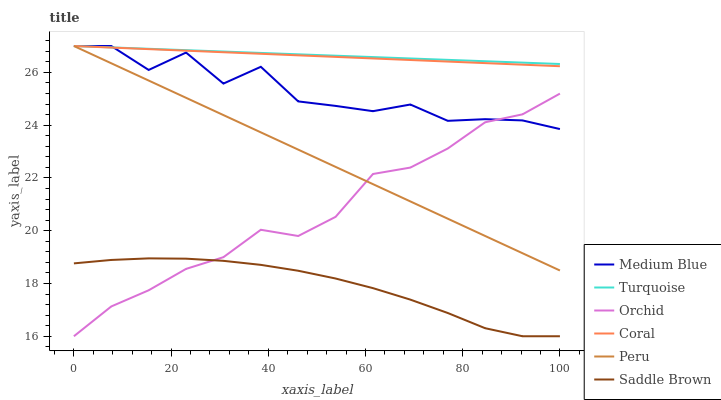Does Saddle Brown have the minimum area under the curve?
Answer yes or no. Yes. Does Turquoise have the maximum area under the curve?
Answer yes or no. Yes. Does Coral have the minimum area under the curve?
Answer yes or no. No. Does Coral have the maximum area under the curve?
Answer yes or no. No. Is Turquoise the smoothest?
Answer yes or no. Yes. Is Medium Blue the roughest?
Answer yes or no. Yes. Is Coral the smoothest?
Answer yes or no. No. Is Coral the roughest?
Answer yes or no. No. Does Saddle Brown have the lowest value?
Answer yes or no. Yes. Does Coral have the lowest value?
Answer yes or no. No. Does Peru have the highest value?
Answer yes or no. Yes. Does Saddle Brown have the highest value?
Answer yes or no. No. Is Saddle Brown less than Peru?
Answer yes or no. Yes. Is Coral greater than Orchid?
Answer yes or no. Yes. Does Peru intersect Turquoise?
Answer yes or no. Yes. Is Peru less than Turquoise?
Answer yes or no. No. Is Peru greater than Turquoise?
Answer yes or no. No. Does Saddle Brown intersect Peru?
Answer yes or no. No. 